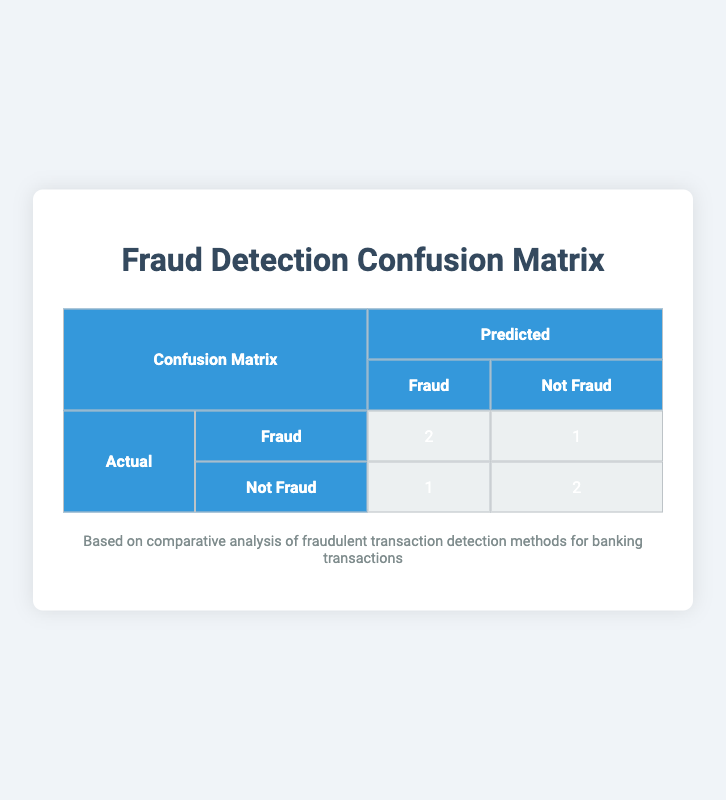What is the number of true positives in the confusion matrix? The confusion matrix shows the cell marked "true-positive," which represents the instances correctly predicted as fraud. In this case, the value is 2.
Answer: 2 How many false negatives are recorded in the table? The cell labeled "false-negative" shows the count of instances that were fraud but were incorrectly predicted as not fraud. This value is 1.
Answer: 1 What is the total number of transactions identified as non-fraudulent? To get the total non-fraudulent transaction count, we sum the true negatives (2) and false positives (1). So, 2 + 1 = 3.
Answer: 3 Is the prediction system more accurate at identifying fraudulent or non-fraudulent transactions? To determine this, we consider the true positives (2) and true negatives (2). Since both are equal and there are no other factors indicating more accuracy, we conclude that it performs equally on both.
Answer: Yes What is the total number of fraudulent transactions predicted by the model? The predicted fraudulent transactions consist of both true positives and false positives. We add these: true positives (2) + false positives (1) = 3.
Answer: 3 How many transactions were actually fraudulent but identified incorrectly? The matrix indicates that there is 1 false negative, meaning one transaction that was fraud was not identified correctly.
Answer: 1 What percentage of actual fraudulent transactions were correctly predicted as fraudulent? There are 3 actual fraudulent transactions (2 true positives + 1 false negative). The correct predictions is 2. So, the percentage is (2/3) * 100 ≈ 66.67%.
Answer: 66.67% What is the accuracy of the model based on the confusion matrix? Accuracy is calculated as the ratio of correctly predicted transactions (true positives + true negatives) to the total transactions. So, (2 + 2) / 6 = 4 / 6 ≈ 66.67%.
Answer: 66.67% How many total fraudulent transactions existed according to the actual labels? The total fraudulent transactions are represented by the actual labels: 2 true positives and 1 false negative, adding to a total of 3 actual fraudulent transactions.
Answer: 3 